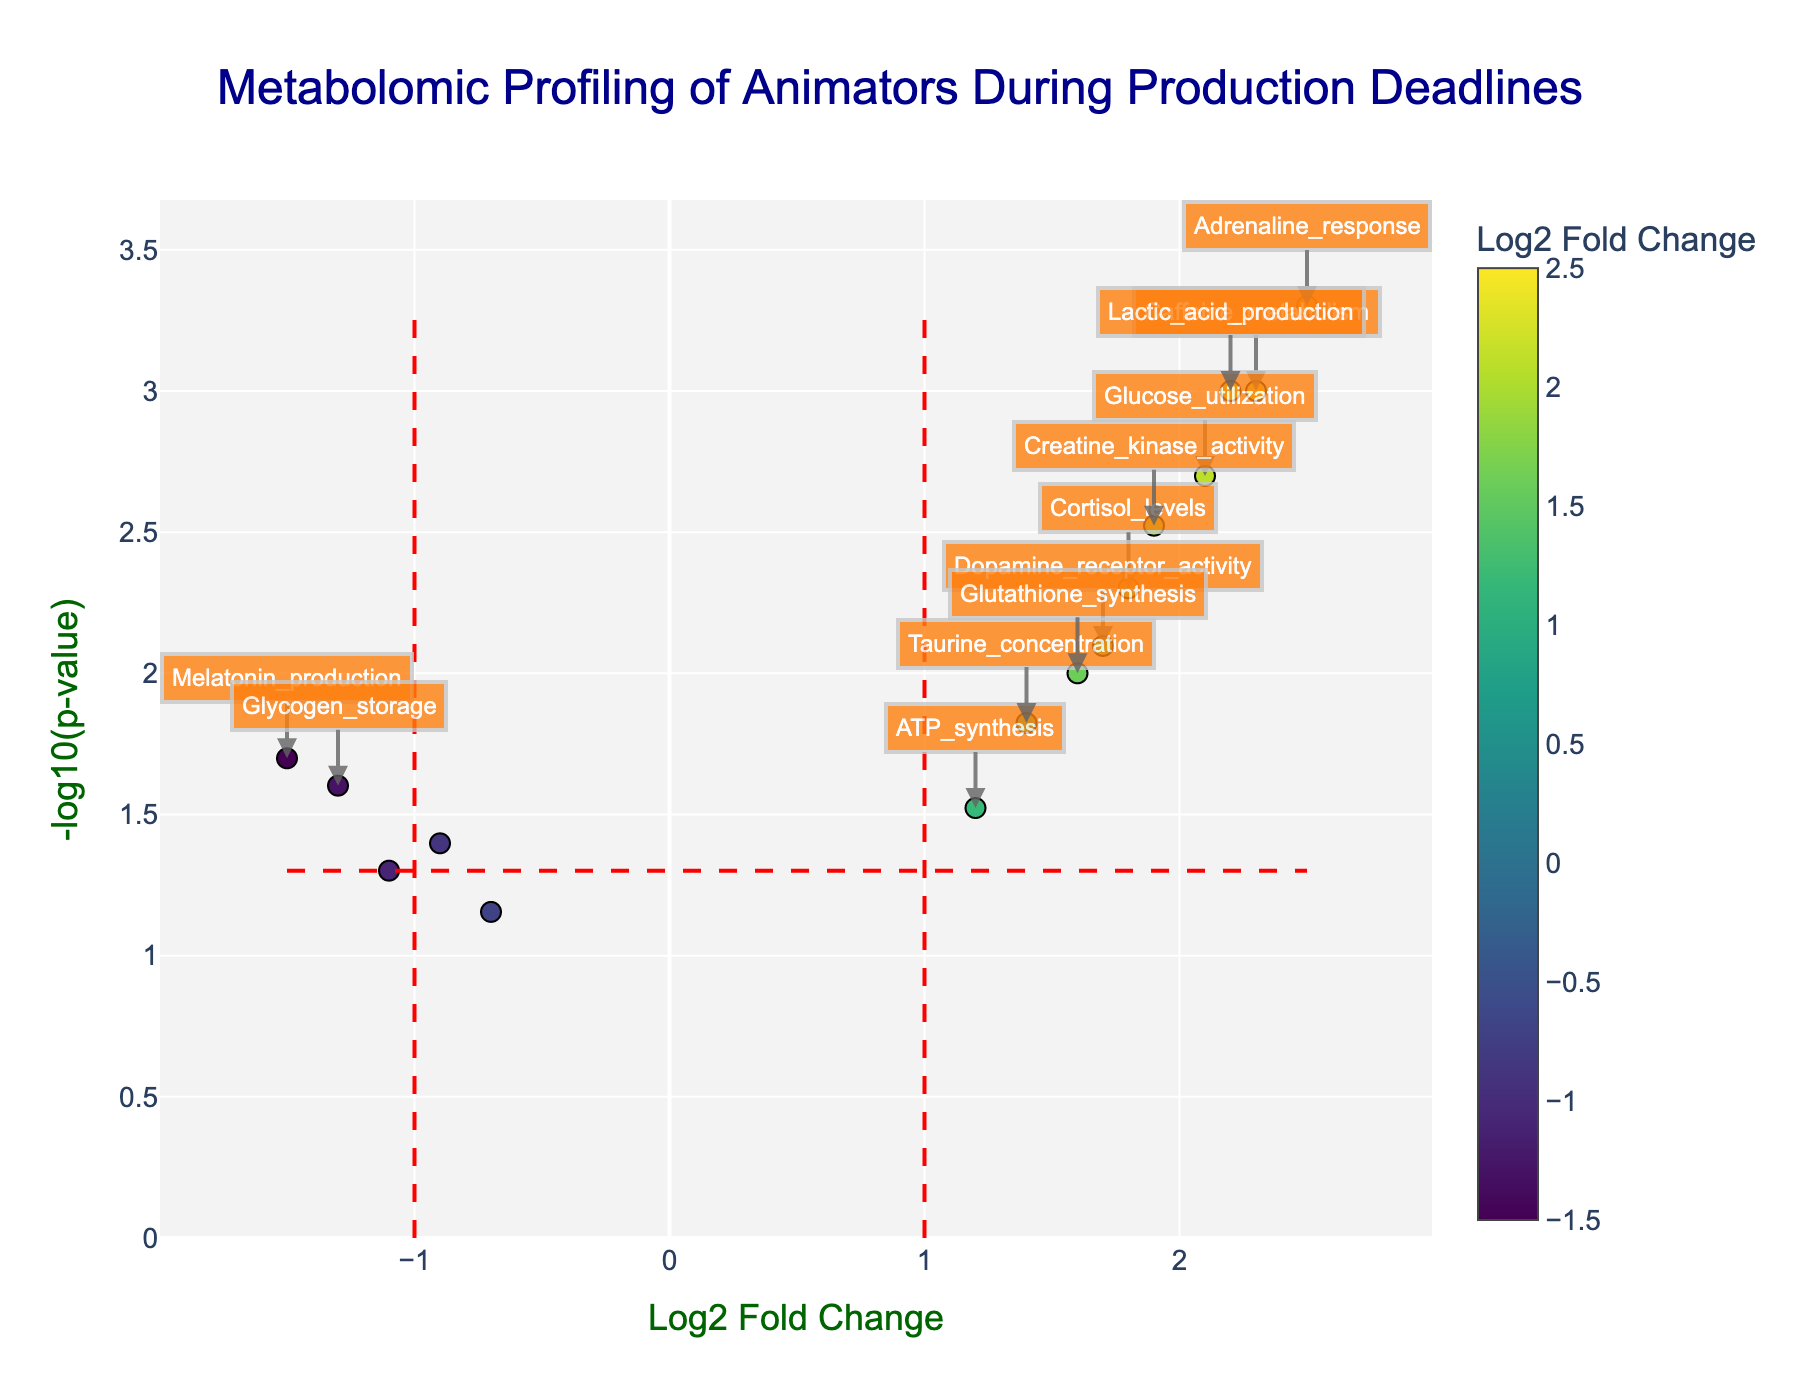What is the title of the figure? The figure includes a title at the top. By observing the top-centre of the plot, the text provided indicates the focus of the plot.
Answer: Metabolomic Profiling of Animators During Production Deadlines What do the x-axis and y-axis represent? The x-axis and y-axis labels indicate the variables being plotted. The x-axis is labeled "Log2 Fold Change," indicating the logarithmic change in expression levels. The y-axis is labeled "-log10(p-value)," representing the significance of the data points.
Answer: The x-axis shows Log2 Fold Change and the y-axis shows -log10(p-value) How many data points (genes) are plotted? By counting each individual marker (point) in the scatter plot, one can determine the total number of data points represented.
Answer: 15 Which gene has the highest -log10(p-value)? Examine the y-axis to find the data point with the highest value. Hover text or annotations can also identify which gene corresponds to that highest point.
Answer: Adrenaline_response Which gene shows the highest positive log2 fold change? Look along the x-axis for the farthest point on the positive side (right direction). Hover text or annotations can provide the gene name.
Answer: Adrenaline_response Are there any genes with a significant negative fold change? Identify points to the left of the y-axis that also meet the vertical red dashed lines indicating significance.
Answer: Yes Which gene has the smallest p-value? The smallest p-value corresponds to the highest -log10(p-value). Find the point with the maximum y value and check its hover text.
Answer: Adrenaline_response What are the thresholds for significance marked on the plot? From the shapes/lines added to the plot, there are two horizontal lines for -log10(p-value) and two vertical lines for log2 fold change. By reading these positions, one can determine the exact threshold values.
Answer: Log2 fold change: ±1, p-value: 0.05 Which gene shows the highest positive fold change in metabolism? Identify the genes related to metabolism and compare their log2 fold changes.
Answer: Lactic_acid_production How many genes have p-values less than 0.01? Consider any gene above -log10(0.01). By examining the data points above a specific y position representing this p-value, count them.
Answer: 6 